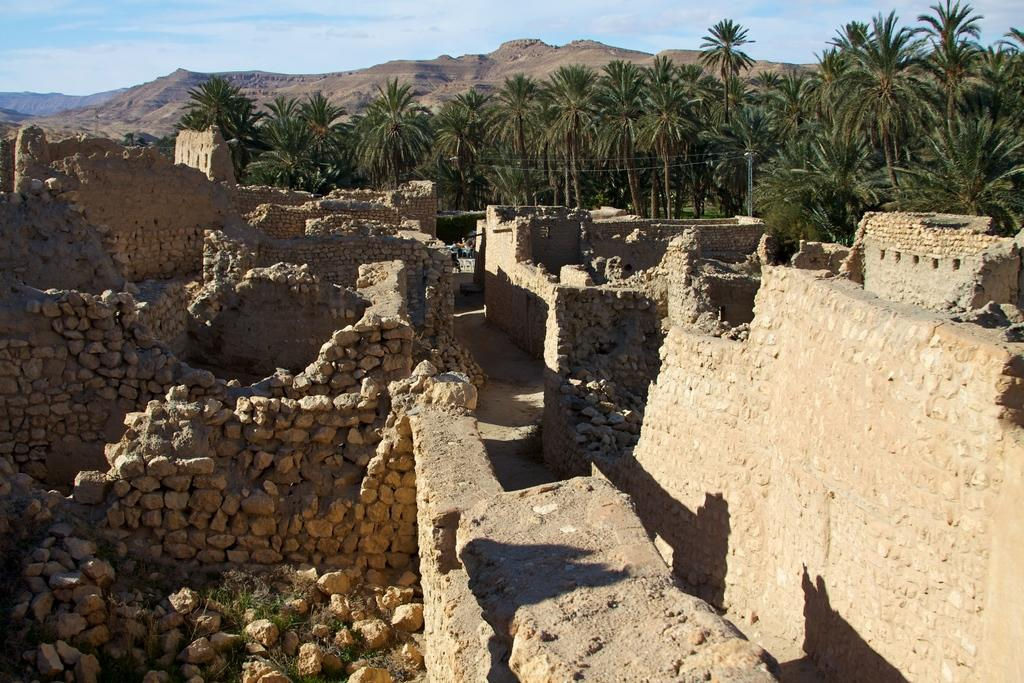What type of natural elements can be seen in the image? There are rocks and trees in the image. What is the color of the sky in the image? The sky is blue in color. Are there any clouds visible in the sky? Yes, the sky is cloudy in the image. What rate of growth can be observed in the bushes in the image? There are no bushes present in the image, so it is not possible to determine a rate of growth. 